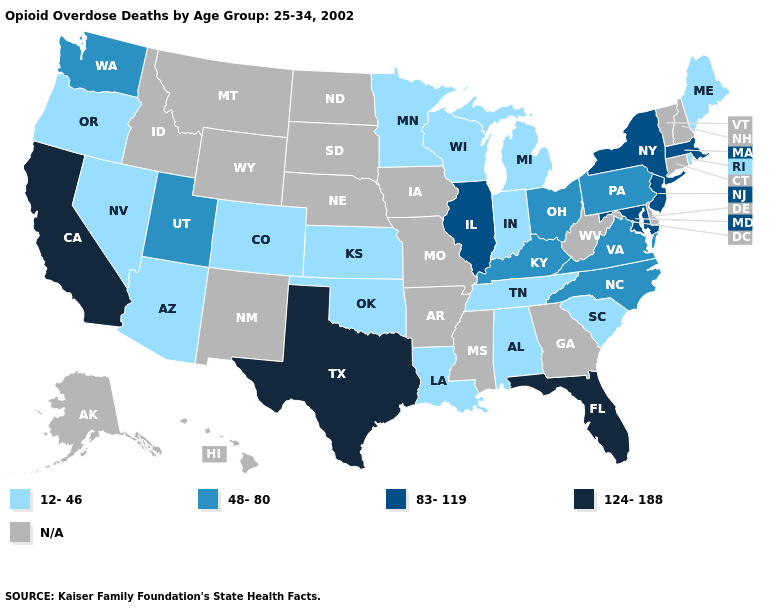What is the highest value in the USA?
Answer briefly. 124-188. How many symbols are there in the legend?
Give a very brief answer. 5. Is the legend a continuous bar?
Answer briefly. No. What is the value of California?
Keep it brief. 124-188. Name the states that have a value in the range 12-46?
Concise answer only. Alabama, Arizona, Colorado, Indiana, Kansas, Louisiana, Maine, Michigan, Minnesota, Nevada, Oklahoma, Oregon, Rhode Island, South Carolina, Tennessee, Wisconsin. Is the legend a continuous bar?
Give a very brief answer. No. Which states hav the highest value in the MidWest?
Concise answer only. Illinois. What is the lowest value in the MidWest?
Write a very short answer. 12-46. Does Oregon have the lowest value in the USA?
Short answer required. Yes. What is the value of New Mexico?
Write a very short answer. N/A. Among the states that border Wyoming , which have the highest value?
Answer briefly. Utah. Does the first symbol in the legend represent the smallest category?
Quick response, please. Yes. What is the value of Montana?
Concise answer only. N/A. Does the map have missing data?
Keep it brief. Yes. Is the legend a continuous bar?
Give a very brief answer. No. 